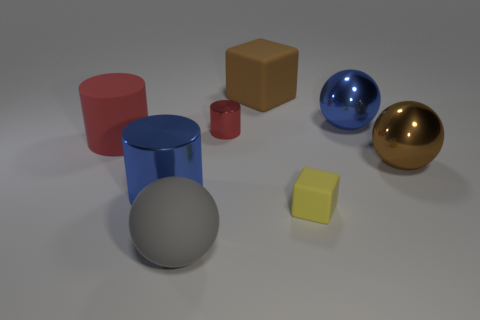What number of things are small things behind the tiny yellow matte block or red objects to the left of the gray sphere?
Provide a short and direct response. 2. There is a metal cylinder in front of the big matte cylinder; is it the same size as the yellow thing that is to the right of the small metal cylinder?
Keep it short and to the point. No. Are there any large blue metal objects that are right of the big blue object that is to the left of the blue metallic ball?
Your answer should be compact. Yes. What number of red metallic cylinders are in front of the red matte thing?
Offer a terse response. 0. What number of other objects are there of the same color as the rubber ball?
Keep it short and to the point. 0. Are there fewer small red cylinders to the right of the big rubber cube than small red metal things that are in front of the large gray matte sphere?
Your answer should be compact. No. How many objects are either rubber objects in front of the large brown metallic object or large blue balls?
Provide a short and direct response. 3. Do the yellow matte block and the red thing in front of the small cylinder have the same size?
Make the answer very short. No. There is a blue object that is the same shape as the big gray thing; what is its size?
Your answer should be very brief. Large. How many big spheres are in front of the matte cube that is to the right of the big brown object behind the big brown shiny object?
Make the answer very short. 1. 